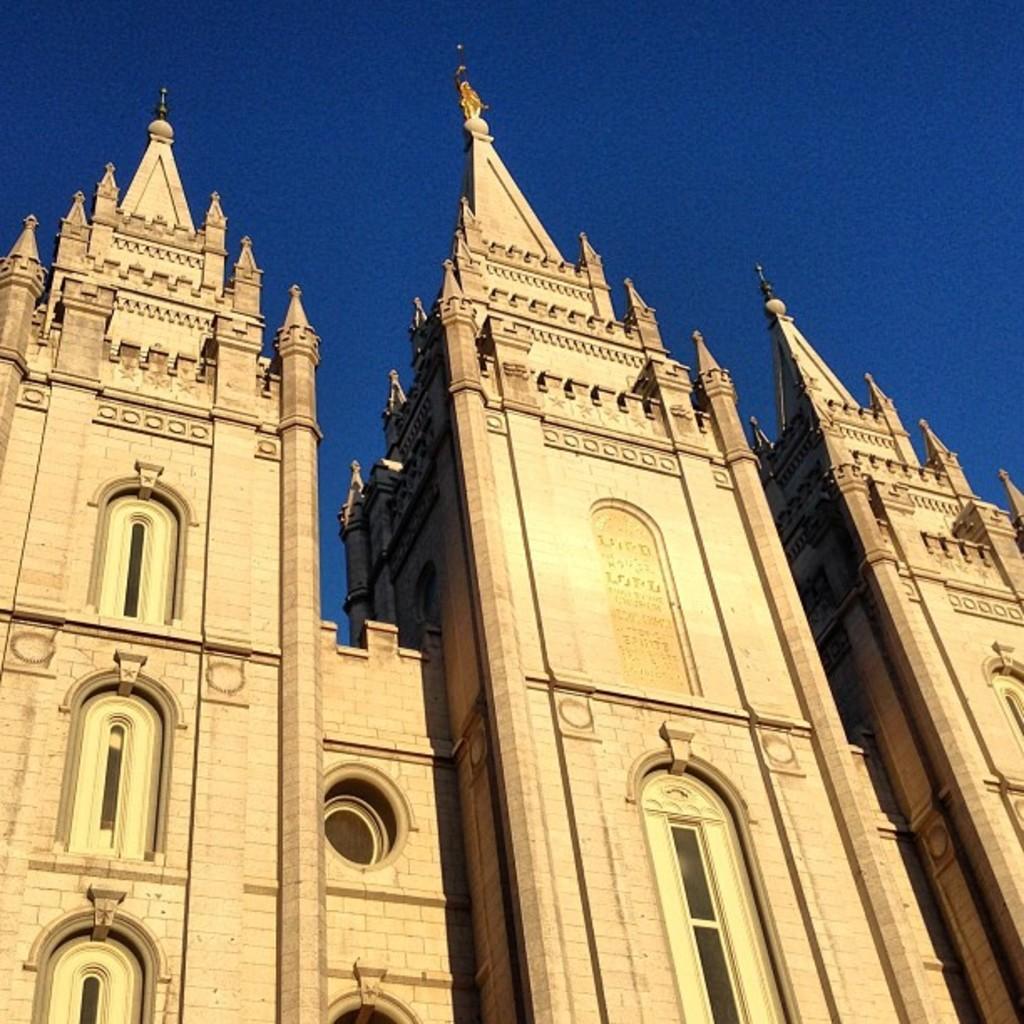Can you describe this image briefly? In this image I can see the buildings which are in brown color. And there is a blue sky in the back. 